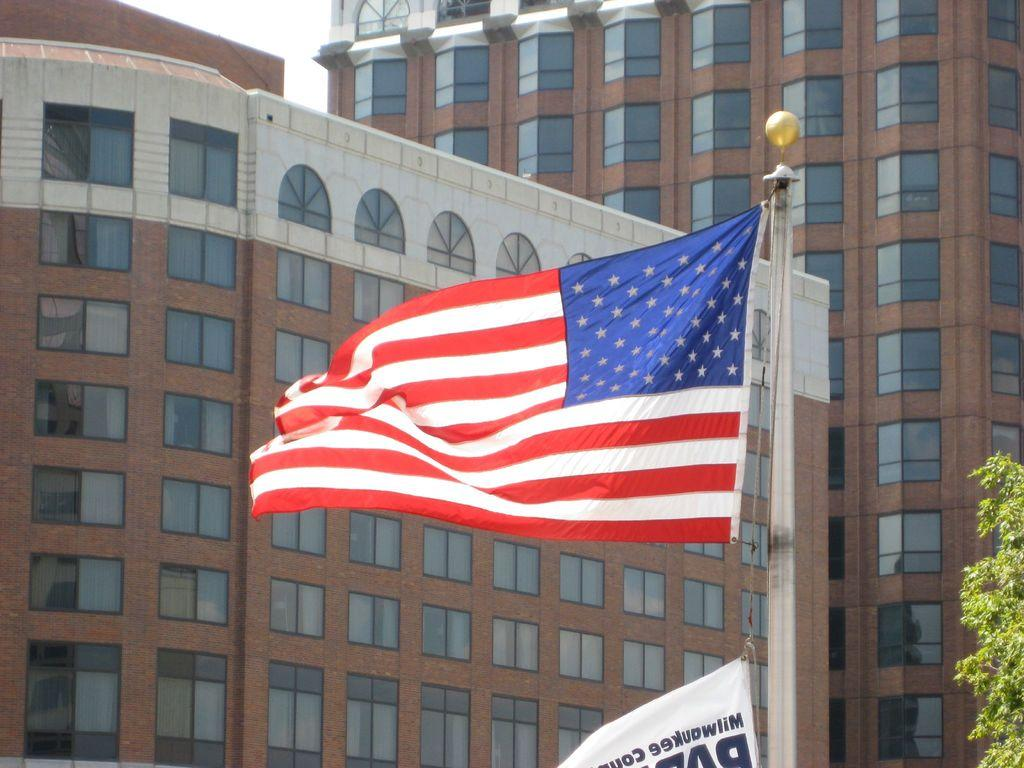What is located in the front of the image? There are flags in the front of the image. What type of vegetation can be seen on the right side of the image? There are leaves on the right side of the image. What can be seen in the background of the image? There are buildings in the background of the image. What language is spoken by the flowers in the image? There are no flowers present in the image, and therefore no language can be attributed to them. Can you describe the sidewalk in the image? There is no sidewalk present in the image. 